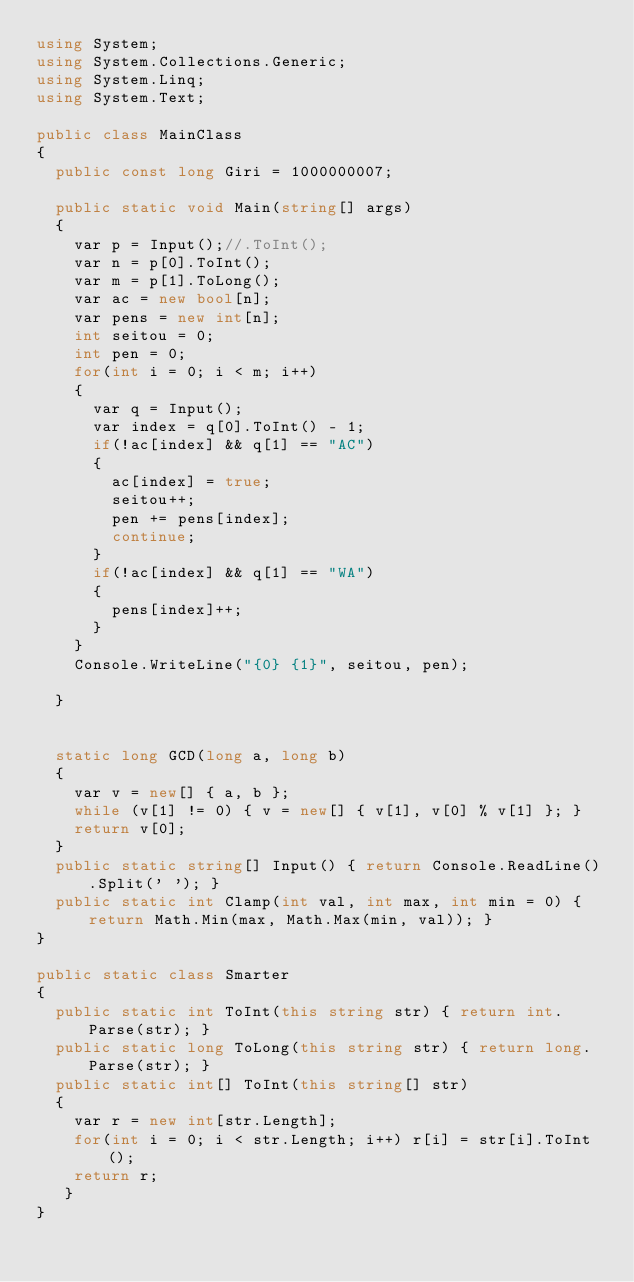<code> <loc_0><loc_0><loc_500><loc_500><_C#_>using System;
using System.Collections.Generic;
using System.Linq;
using System.Text;

public class MainClass
{
	public const long Giri = 1000000007;

	public static void Main(string[] args)
	{
		var p = Input();//.ToInt();
		var n = p[0].ToInt();
		var m = p[1].ToLong();
		var ac = new bool[n];
		var pens = new int[n];
		int seitou = 0;
		int pen = 0;
		for(int i = 0; i < m; i++)
		{
			var q = Input();
			var index = q[0].ToInt() - 1;
			if(!ac[index] && q[1] == "AC")
			{
				ac[index] = true;
				seitou++;
				pen += pens[index];
				continue;
			}
			if(!ac[index] && q[1] == "WA")
			{
				pens[index]++;
			}
		}
		Console.WriteLine("{0} {1}", seitou, pen);
		
	}
	

	static long GCD(long a, long b)
	{
		var v = new[] { a, b };
		while (v[1] != 0) { v = new[] { v[1], v[0] % v[1] }; }
		return v[0];
	}
	public static string[] Input() { return Console.ReadLine().Split(' '); }
	public static int Clamp(int val, int max, int min = 0) { return Math.Min(max, Math.Max(min, val)); }
}

public static class Smarter
{
	public static int ToInt(this string str) { return int.Parse(str); }
	public static long ToLong(this string str) { return long.Parse(str); }
	public static int[] ToInt(this string[] str)
	{
		var r = new int[str.Length];
		for(int i = 0; i < str.Length; i++) r[i] = str[i].ToInt();
		return r;
	 }
}
</code> 